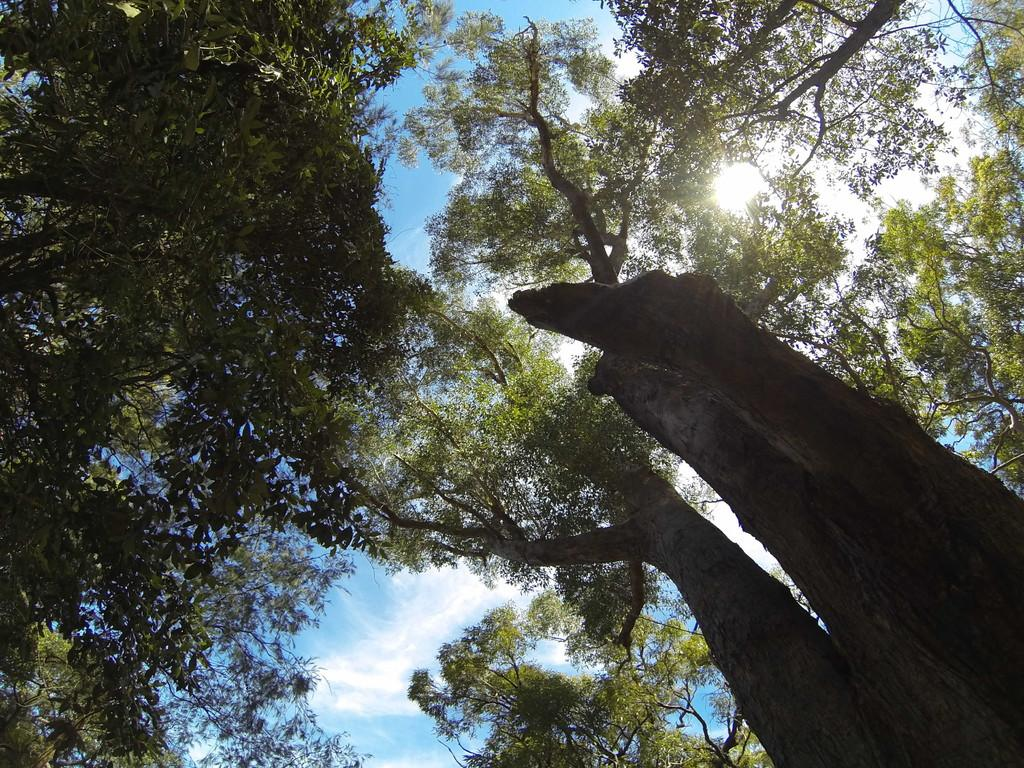What type of vegetation can be seen in the image? There are trees in the image. What part of the natural environment is visible in the image? The sky is visible in the image. Can the sun be seen in the image? Yes, the sun is observable in the sky. What else can be seen in the sky? Clouds are present in the sky. What type of pets are visible in the image? There are no pets present in the image. What type of teeth can be seen in the image? There are no teeth visible in the image. 